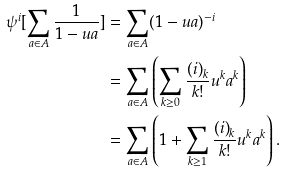<formula> <loc_0><loc_0><loc_500><loc_500>\psi ^ { i } [ \sum _ { a \in A } \frac { 1 } { 1 - u a } ] & = \sum _ { a \in A } ( 1 - u a ) ^ { - i } \\ & = \sum _ { a \in A } \left ( \sum _ { k \geq 0 } \frac { { ( i ) } _ { k } } { k ! } u ^ { k } a ^ { k } \right ) \\ & = \sum _ { a \in A } \left ( 1 + \sum _ { k \geq 1 } \frac { { ( i ) } _ { k } } { k ! } u ^ { k } a ^ { k } \right ) .</formula> 